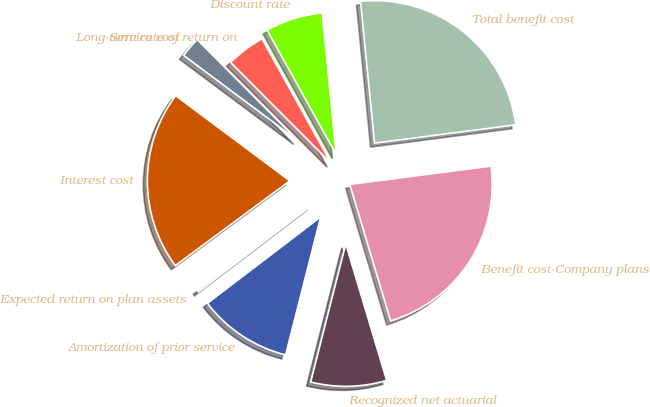<chart> <loc_0><loc_0><loc_500><loc_500><pie_chart><fcel>Service cost<fcel>Interest cost<fcel>Expected return on plan assets<fcel>Amortization of prior service<fcel>Recognized net actuarial<fcel>Benefit cost-Company plans<fcel>Total benefit cost<fcel>Discount rate<fcel>Long-term rate of return on<nl><fcel>2.32%<fcel>20.34%<fcel>0.23%<fcel>10.67%<fcel>8.59%<fcel>22.42%<fcel>24.51%<fcel>6.5%<fcel>4.41%<nl></chart> 